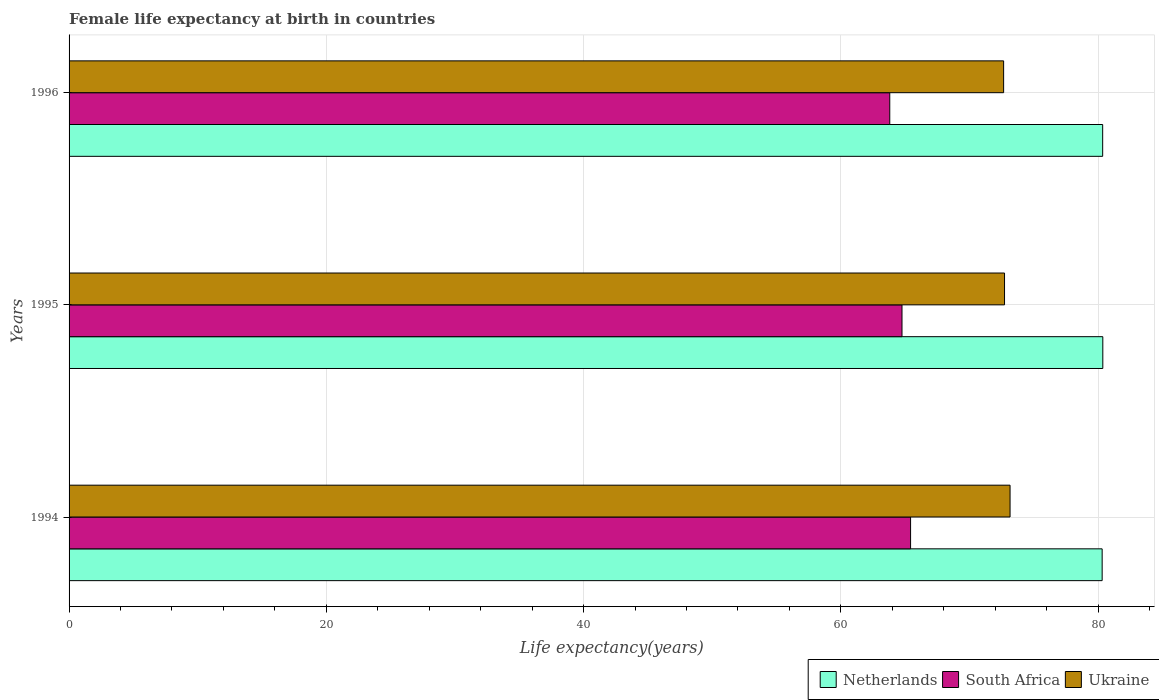How many groups of bars are there?
Ensure brevity in your answer.  3. Are the number of bars per tick equal to the number of legend labels?
Make the answer very short. Yes. How many bars are there on the 1st tick from the bottom?
Keep it short and to the point. 3. In how many cases, is the number of bars for a given year not equal to the number of legend labels?
Ensure brevity in your answer.  0. What is the female life expectancy at birth in South Africa in 1996?
Give a very brief answer. 63.8. Across all years, what is the maximum female life expectancy at birth in South Africa?
Give a very brief answer. 65.42. Across all years, what is the minimum female life expectancy at birth in South Africa?
Your response must be concise. 63.8. What is the total female life expectancy at birth in Ukraine in the graph?
Make the answer very short. 218.52. What is the difference between the female life expectancy at birth in Netherlands in 1994 and that in 1995?
Provide a succinct answer. -0.05. What is the difference between the female life expectancy at birth in Ukraine in 1996 and the female life expectancy at birth in Netherlands in 1995?
Ensure brevity in your answer.  -7.71. What is the average female life expectancy at birth in South Africa per year?
Offer a terse response. 64.66. In the year 1994, what is the difference between the female life expectancy at birth in South Africa and female life expectancy at birth in Netherlands?
Provide a succinct answer. -14.89. What is the ratio of the female life expectancy at birth in Netherlands in 1995 to that in 1996?
Give a very brief answer. 1. Is the female life expectancy at birth in Netherlands in 1994 less than that in 1995?
Provide a short and direct response. Yes. Is the difference between the female life expectancy at birth in South Africa in 1994 and 1995 greater than the difference between the female life expectancy at birth in Netherlands in 1994 and 1995?
Provide a short and direct response. Yes. What is the difference between the highest and the second highest female life expectancy at birth in Ukraine?
Your answer should be compact. 0.43. What is the difference between the highest and the lowest female life expectancy at birth in Netherlands?
Offer a very short reply. 0.05. In how many years, is the female life expectancy at birth in Netherlands greater than the average female life expectancy at birth in Netherlands taken over all years?
Offer a very short reply. 2. What does the 2nd bar from the top in 1996 represents?
Your answer should be very brief. South Africa. What does the 2nd bar from the bottom in 1996 represents?
Offer a very short reply. South Africa. Is it the case that in every year, the sum of the female life expectancy at birth in Netherlands and female life expectancy at birth in South Africa is greater than the female life expectancy at birth in Ukraine?
Your answer should be very brief. Yes. How many bars are there?
Keep it short and to the point. 9. Are all the bars in the graph horizontal?
Your answer should be very brief. Yes. How many years are there in the graph?
Offer a terse response. 3. Does the graph contain grids?
Ensure brevity in your answer.  Yes. Where does the legend appear in the graph?
Offer a very short reply. Bottom right. What is the title of the graph?
Ensure brevity in your answer.  Female life expectancy at birth in countries. Does "Brazil" appear as one of the legend labels in the graph?
Ensure brevity in your answer.  No. What is the label or title of the X-axis?
Make the answer very short. Life expectancy(years). What is the Life expectancy(years) of Netherlands in 1994?
Give a very brief answer. 80.31. What is the Life expectancy(years) in South Africa in 1994?
Keep it short and to the point. 65.42. What is the Life expectancy(years) in Ukraine in 1994?
Your answer should be compact. 73.15. What is the Life expectancy(years) in Netherlands in 1995?
Your response must be concise. 80.36. What is the Life expectancy(years) in South Africa in 1995?
Give a very brief answer. 64.75. What is the Life expectancy(years) of Ukraine in 1995?
Your answer should be compact. 72.72. What is the Life expectancy(years) in Netherlands in 1996?
Give a very brief answer. 80.35. What is the Life expectancy(years) of South Africa in 1996?
Ensure brevity in your answer.  63.8. What is the Life expectancy(years) in Ukraine in 1996?
Offer a very short reply. 72.65. Across all years, what is the maximum Life expectancy(years) of Netherlands?
Provide a succinct answer. 80.36. Across all years, what is the maximum Life expectancy(years) of South Africa?
Provide a short and direct response. 65.42. Across all years, what is the maximum Life expectancy(years) in Ukraine?
Make the answer very short. 73.15. Across all years, what is the minimum Life expectancy(years) of Netherlands?
Your response must be concise. 80.31. Across all years, what is the minimum Life expectancy(years) in South Africa?
Make the answer very short. 63.8. Across all years, what is the minimum Life expectancy(years) of Ukraine?
Ensure brevity in your answer.  72.65. What is the total Life expectancy(years) of Netherlands in the graph?
Offer a terse response. 241.02. What is the total Life expectancy(years) in South Africa in the graph?
Give a very brief answer. 193.97. What is the total Life expectancy(years) in Ukraine in the graph?
Offer a very short reply. 218.52. What is the difference between the Life expectancy(years) of Netherlands in 1994 and that in 1995?
Your answer should be very brief. -0.05. What is the difference between the Life expectancy(years) in South Africa in 1994 and that in 1995?
Keep it short and to the point. 0.67. What is the difference between the Life expectancy(years) in Ukraine in 1994 and that in 1995?
Your response must be concise. 0.43. What is the difference between the Life expectancy(years) in Netherlands in 1994 and that in 1996?
Your answer should be compact. -0.04. What is the difference between the Life expectancy(years) of South Africa in 1994 and that in 1996?
Your response must be concise. 1.62. What is the difference between the Life expectancy(years) in Ukraine in 1994 and that in 1996?
Offer a terse response. 0.5. What is the difference between the Life expectancy(years) of Netherlands in 1995 and that in 1996?
Offer a terse response. 0.01. What is the difference between the Life expectancy(years) of South Africa in 1995 and that in 1996?
Give a very brief answer. 0.95. What is the difference between the Life expectancy(years) of Ukraine in 1995 and that in 1996?
Keep it short and to the point. 0.07. What is the difference between the Life expectancy(years) of Netherlands in 1994 and the Life expectancy(years) of South Africa in 1995?
Ensure brevity in your answer.  15.56. What is the difference between the Life expectancy(years) in Netherlands in 1994 and the Life expectancy(years) in Ukraine in 1995?
Offer a very short reply. 7.59. What is the difference between the Life expectancy(years) of South Africa in 1994 and the Life expectancy(years) of Ukraine in 1995?
Your answer should be very brief. -7.3. What is the difference between the Life expectancy(years) of Netherlands in 1994 and the Life expectancy(years) of South Africa in 1996?
Offer a terse response. 16.51. What is the difference between the Life expectancy(years) of Netherlands in 1994 and the Life expectancy(years) of Ukraine in 1996?
Offer a terse response. 7.66. What is the difference between the Life expectancy(years) of South Africa in 1994 and the Life expectancy(years) of Ukraine in 1996?
Offer a terse response. -7.23. What is the difference between the Life expectancy(years) in Netherlands in 1995 and the Life expectancy(years) in South Africa in 1996?
Give a very brief answer. 16.56. What is the difference between the Life expectancy(years) of Netherlands in 1995 and the Life expectancy(years) of Ukraine in 1996?
Provide a succinct answer. 7.71. What is the difference between the Life expectancy(years) of South Africa in 1995 and the Life expectancy(years) of Ukraine in 1996?
Keep it short and to the point. -7.9. What is the average Life expectancy(years) of Netherlands per year?
Provide a short and direct response. 80.34. What is the average Life expectancy(years) in South Africa per year?
Ensure brevity in your answer.  64.66. What is the average Life expectancy(years) of Ukraine per year?
Provide a succinct answer. 72.84. In the year 1994, what is the difference between the Life expectancy(years) in Netherlands and Life expectancy(years) in South Africa?
Your response must be concise. 14.89. In the year 1994, what is the difference between the Life expectancy(years) of Netherlands and Life expectancy(years) of Ukraine?
Give a very brief answer. 7.16. In the year 1994, what is the difference between the Life expectancy(years) of South Africa and Life expectancy(years) of Ukraine?
Provide a succinct answer. -7.73. In the year 1995, what is the difference between the Life expectancy(years) of Netherlands and Life expectancy(years) of South Africa?
Your answer should be very brief. 15.61. In the year 1995, what is the difference between the Life expectancy(years) in Netherlands and Life expectancy(years) in Ukraine?
Make the answer very short. 7.64. In the year 1995, what is the difference between the Life expectancy(years) of South Africa and Life expectancy(years) of Ukraine?
Your answer should be very brief. -7.97. In the year 1996, what is the difference between the Life expectancy(years) in Netherlands and Life expectancy(years) in South Africa?
Offer a very short reply. 16.55. In the year 1996, what is the difference between the Life expectancy(years) of South Africa and Life expectancy(years) of Ukraine?
Offer a terse response. -8.85. What is the ratio of the Life expectancy(years) in South Africa in 1994 to that in 1995?
Your answer should be compact. 1.01. What is the ratio of the Life expectancy(years) of Ukraine in 1994 to that in 1995?
Make the answer very short. 1.01. What is the ratio of the Life expectancy(years) in Netherlands in 1994 to that in 1996?
Provide a short and direct response. 1. What is the ratio of the Life expectancy(years) in South Africa in 1994 to that in 1996?
Keep it short and to the point. 1.03. What is the ratio of the Life expectancy(years) of Ukraine in 1994 to that in 1996?
Ensure brevity in your answer.  1.01. What is the ratio of the Life expectancy(years) in South Africa in 1995 to that in 1996?
Offer a very short reply. 1.01. What is the difference between the highest and the second highest Life expectancy(years) of South Africa?
Ensure brevity in your answer.  0.67. What is the difference between the highest and the second highest Life expectancy(years) in Ukraine?
Your answer should be compact. 0.43. What is the difference between the highest and the lowest Life expectancy(years) in Netherlands?
Offer a very short reply. 0.05. What is the difference between the highest and the lowest Life expectancy(years) of South Africa?
Make the answer very short. 1.62. What is the difference between the highest and the lowest Life expectancy(years) of Ukraine?
Your answer should be very brief. 0.5. 